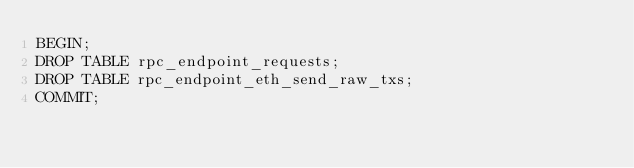<code> <loc_0><loc_0><loc_500><loc_500><_SQL_>BEGIN;
DROP TABLE rpc_endpoint_requests;
DROP TABLE rpc_endpoint_eth_send_raw_txs;
COMMIT;</code> 